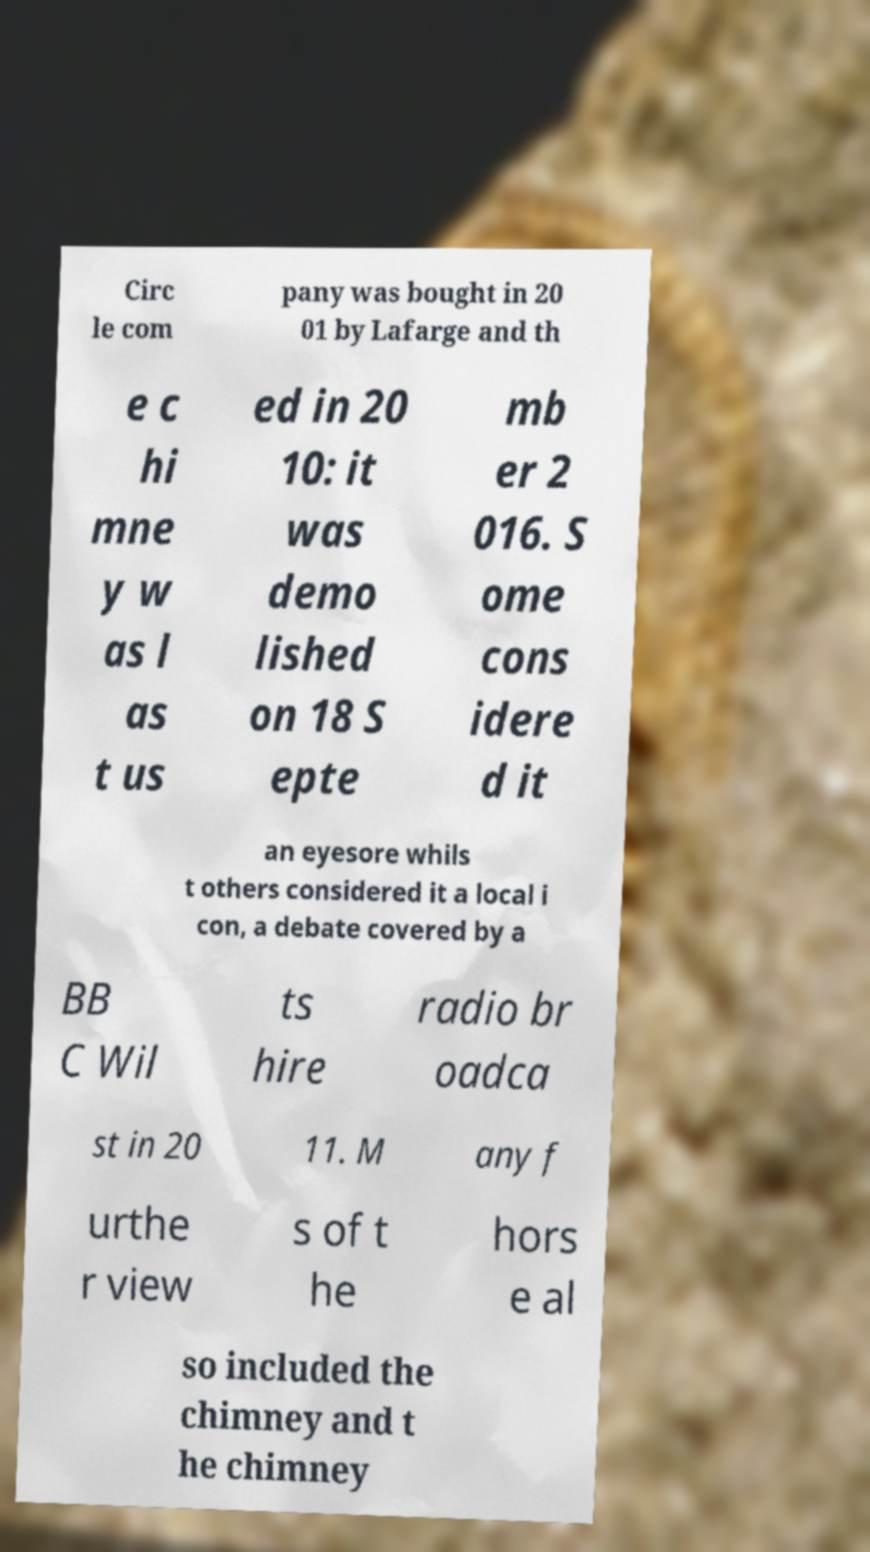Please read and relay the text visible in this image. What does it say? Circ le com pany was bought in 20 01 by Lafarge and th e c hi mne y w as l as t us ed in 20 10: it was demo lished on 18 S epte mb er 2 016. S ome cons idere d it an eyesore whils t others considered it a local i con, a debate covered by a BB C Wil ts hire radio br oadca st in 20 11. M any f urthe r view s of t he hors e al so included the chimney and t he chimney 